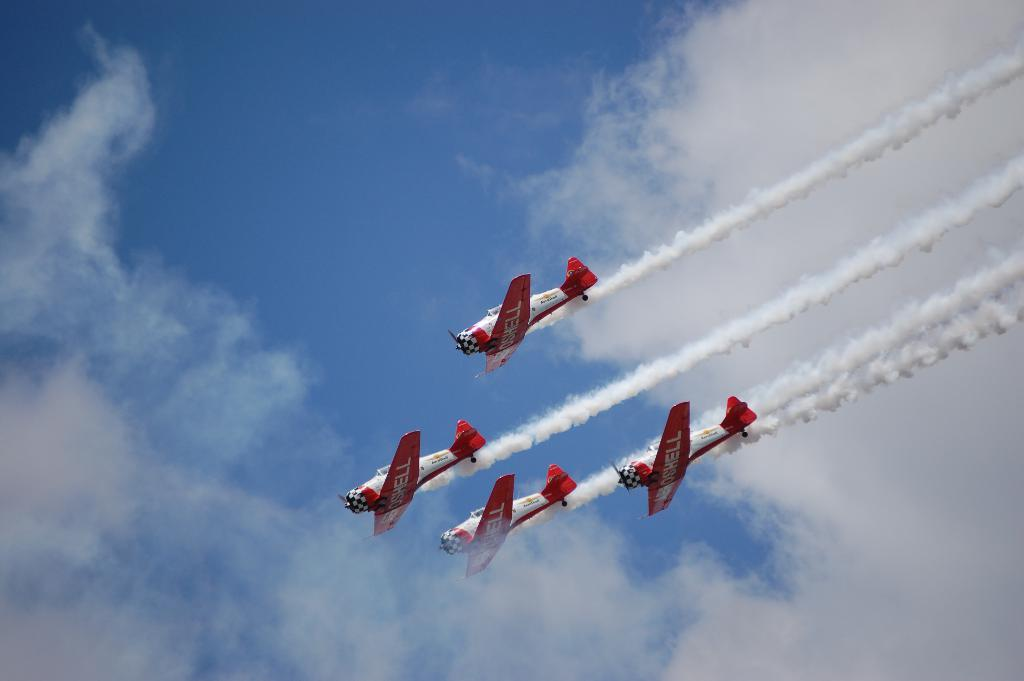How many airplanes are in the image? There are four airplanes in the image. What are the airplanes doing in the image? The airplanes are flying in the air. What colors are the airplanes? The airplanes are white and red in color. What else can be seen in the image besides the airplanes? There is smoke visible in the image. What is visible in the background of the image? The sky is visible in the background of the image. How many bridges can be seen in the image? A: There are no bridges present in the image. What type of arm is visible in the image? There are no arms visible in the image. 